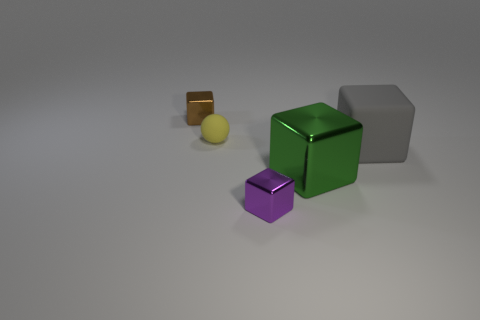What is the size of the purple object that is the same shape as the tiny brown metal object? The purple object in the image appears to be a small cube, similar in shape to the brown object but slightly larger in size. Both objects have the same cubic shape, with the purple one being the larger of the two in this particular arrangement. 